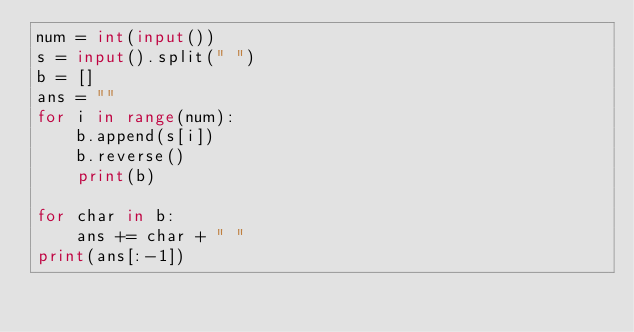Convert code to text. <code><loc_0><loc_0><loc_500><loc_500><_Python_>num = int(input())
s = input().split(" ")
b = []
ans = ""
for i in range(num):
    b.append(s[i])
    b.reverse()
    print(b)

for char in b:
    ans += char + " "
print(ans[:-1])</code> 